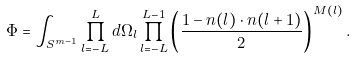<formula> <loc_0><loc_0><loc_500><loc_500>\Phi = \int _ { S ^ { m - 1 } } \prod ^ { L } _ { l = - L } d \Omega _ { l } \prod _ { l = - L } ^ { L - 1 } \left ( \frac { 1 - { n } ( l ) \cdot { n } ( l + 1 ) } { 2 } \right ) ^ { M ( l ) } .</formula> 